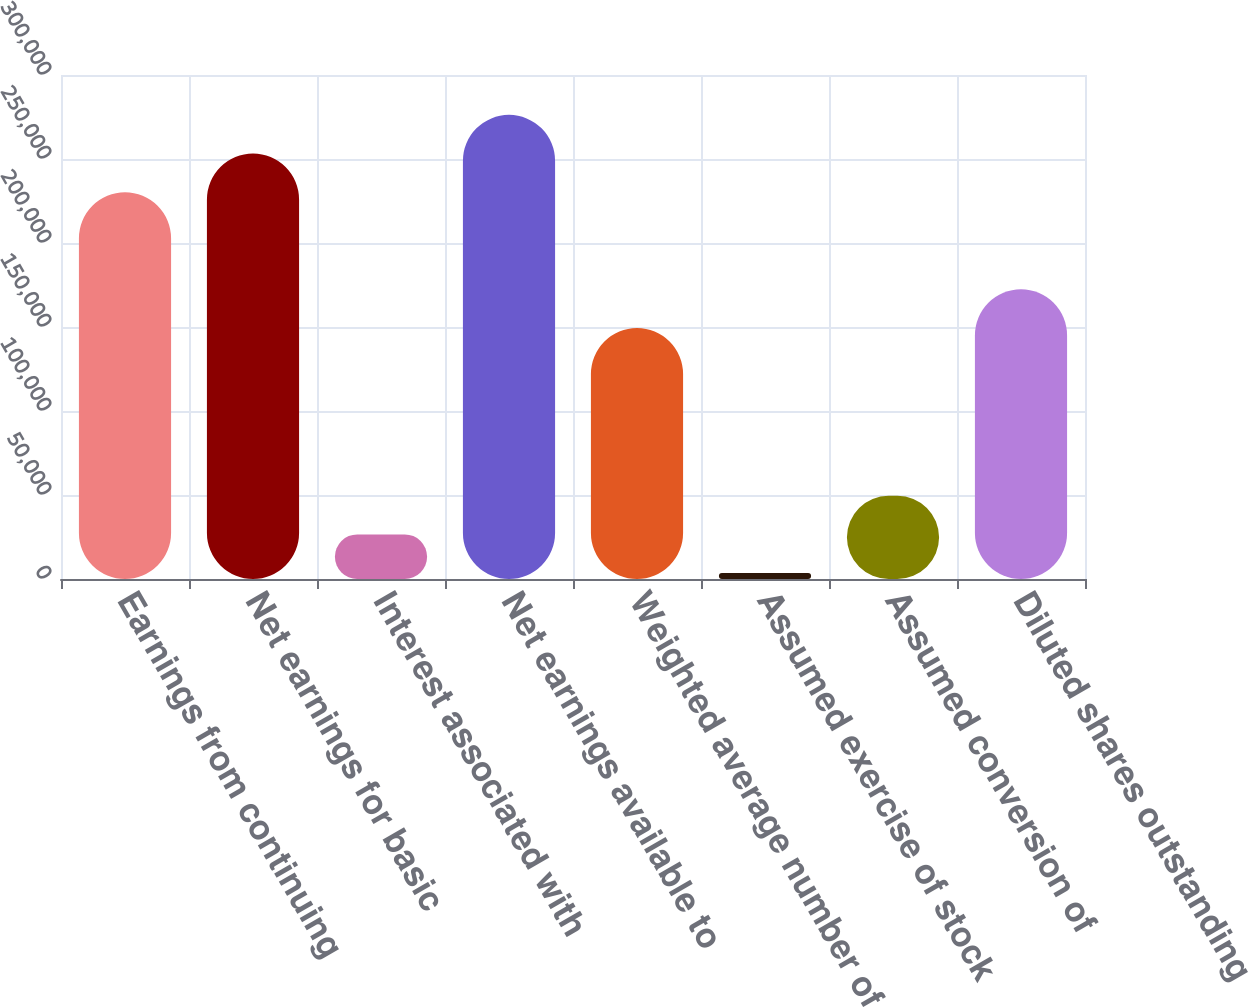Convert chart. <chart><loc_0><loc_0><loc_500><loc_500><bar_chart><fcel>Earnings from continuing<fcel>Net earnings for basic<fcel>Interest associated with<fcel>Net earnings available to<fcel>Weighted average number of<fcel>Assumed exercise of stock<fcel>Assumed conversion of<fcel>Diluted shares outstanding<nl><fcel>230213<fcel>253241<fcel>26546<fcel>276269<fcel>149405<fcel>3518<fcel>49574<fcel>172433<nl></chart> 